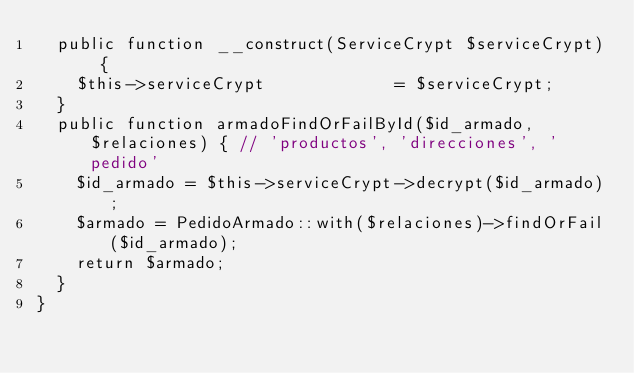<code> <loc_0><loc_0><loc_500><loc_500><_PHP_>  public function __construct(ServiceCrypt $serviceCrypt) {
    $this->serviceCrypt             = $serviceCrypt;
  } 
  public function armadoFindOrFailById($id_armado, $relaciones) { // 'productos', 'direcciones', 'pedido'
    $id_armado = $this->serviceCrypt->decrypt($id_armado);
    $armado = PedidoArmado::with($relaciones)->findOrFail($id_armado);
    return $armado;
  }
}</code> 